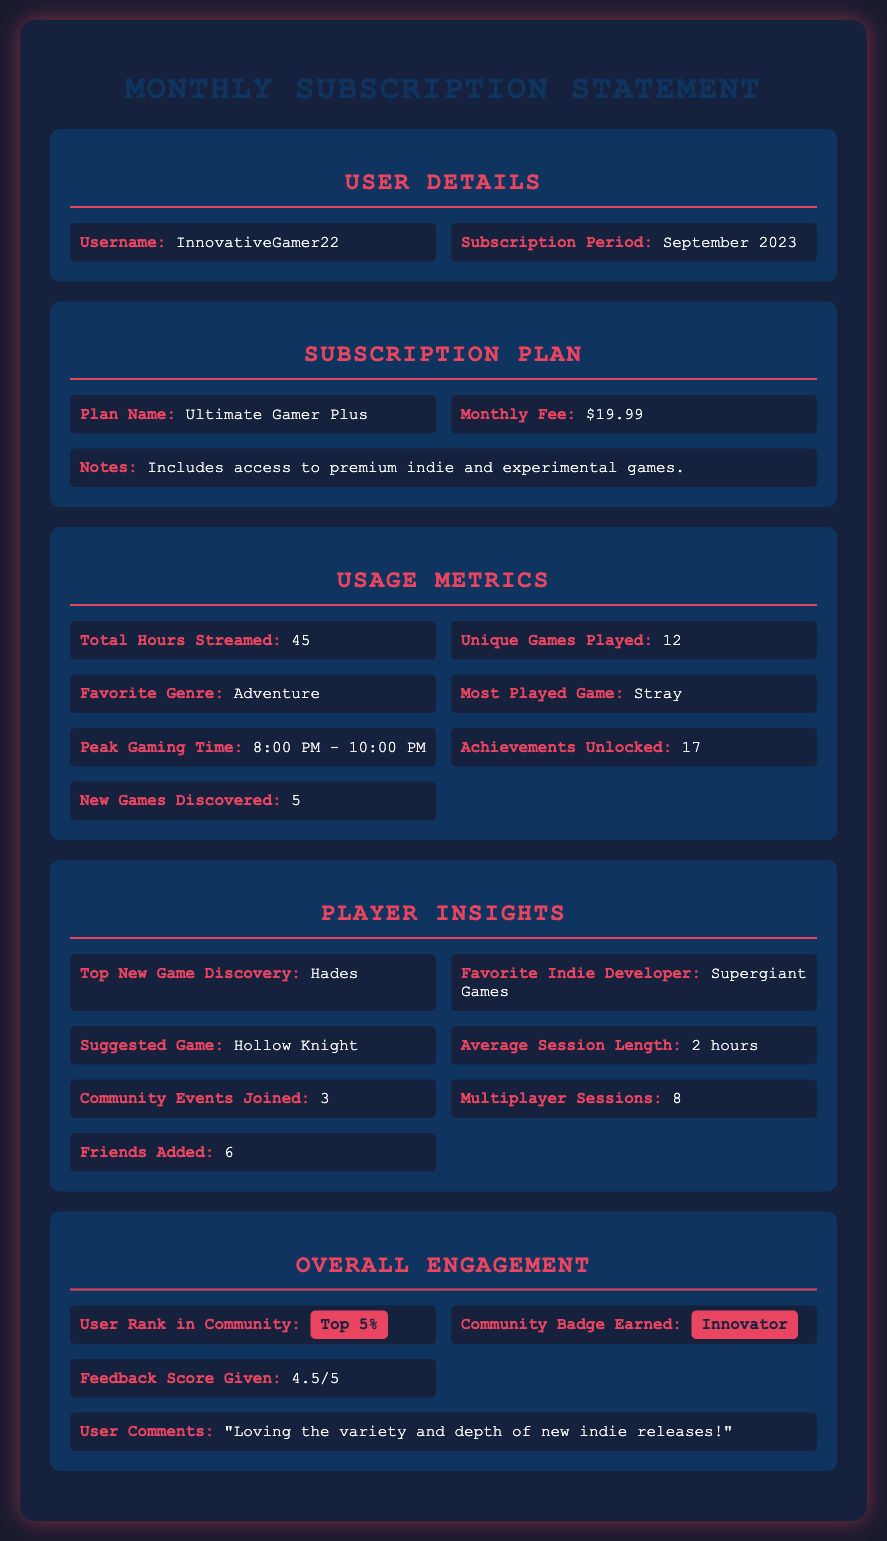What is the username? The username is specifically mentioned in the User Details section of the document.
Answer: InnovativeGamer22 What is the subscription fee? The subscription fee is included in the Subscription Plan section, indicating the monthly charge for the service.
Answer: $19.99 How many unique games were played? The number of unique games played is detailed under the Usage Metrics section.
Answer: 12 What is the most played game? The most played game is stated in the Usage Metrics section and refers to the game that received the most playtime.
Answer: Stray What is the user's average session length? The average session length is presented in the Player Insights section and describes the typical duration of gaming sessions.
Answer: 2 hours Which community badge was earned? The earned community badge is shown in the Overall Engagement section, indicating recognition within the gaming community.
Answer: Innovator What percentage is the user's rank in the community? The rank in the community is found in the Overall Engagement section and indicates the user's standing among peers.
Answer: Top 5% What is the feedback score given? The feedback score can be found in the Overall Engagement section, reflecting the user's rating of their gaming experience.
Answer: 4.5/5 How many new games were discovered? The number of new games discovered is listed in the Usage Metrics section and represents the fresh titles the user encountered.
Answer: 5 